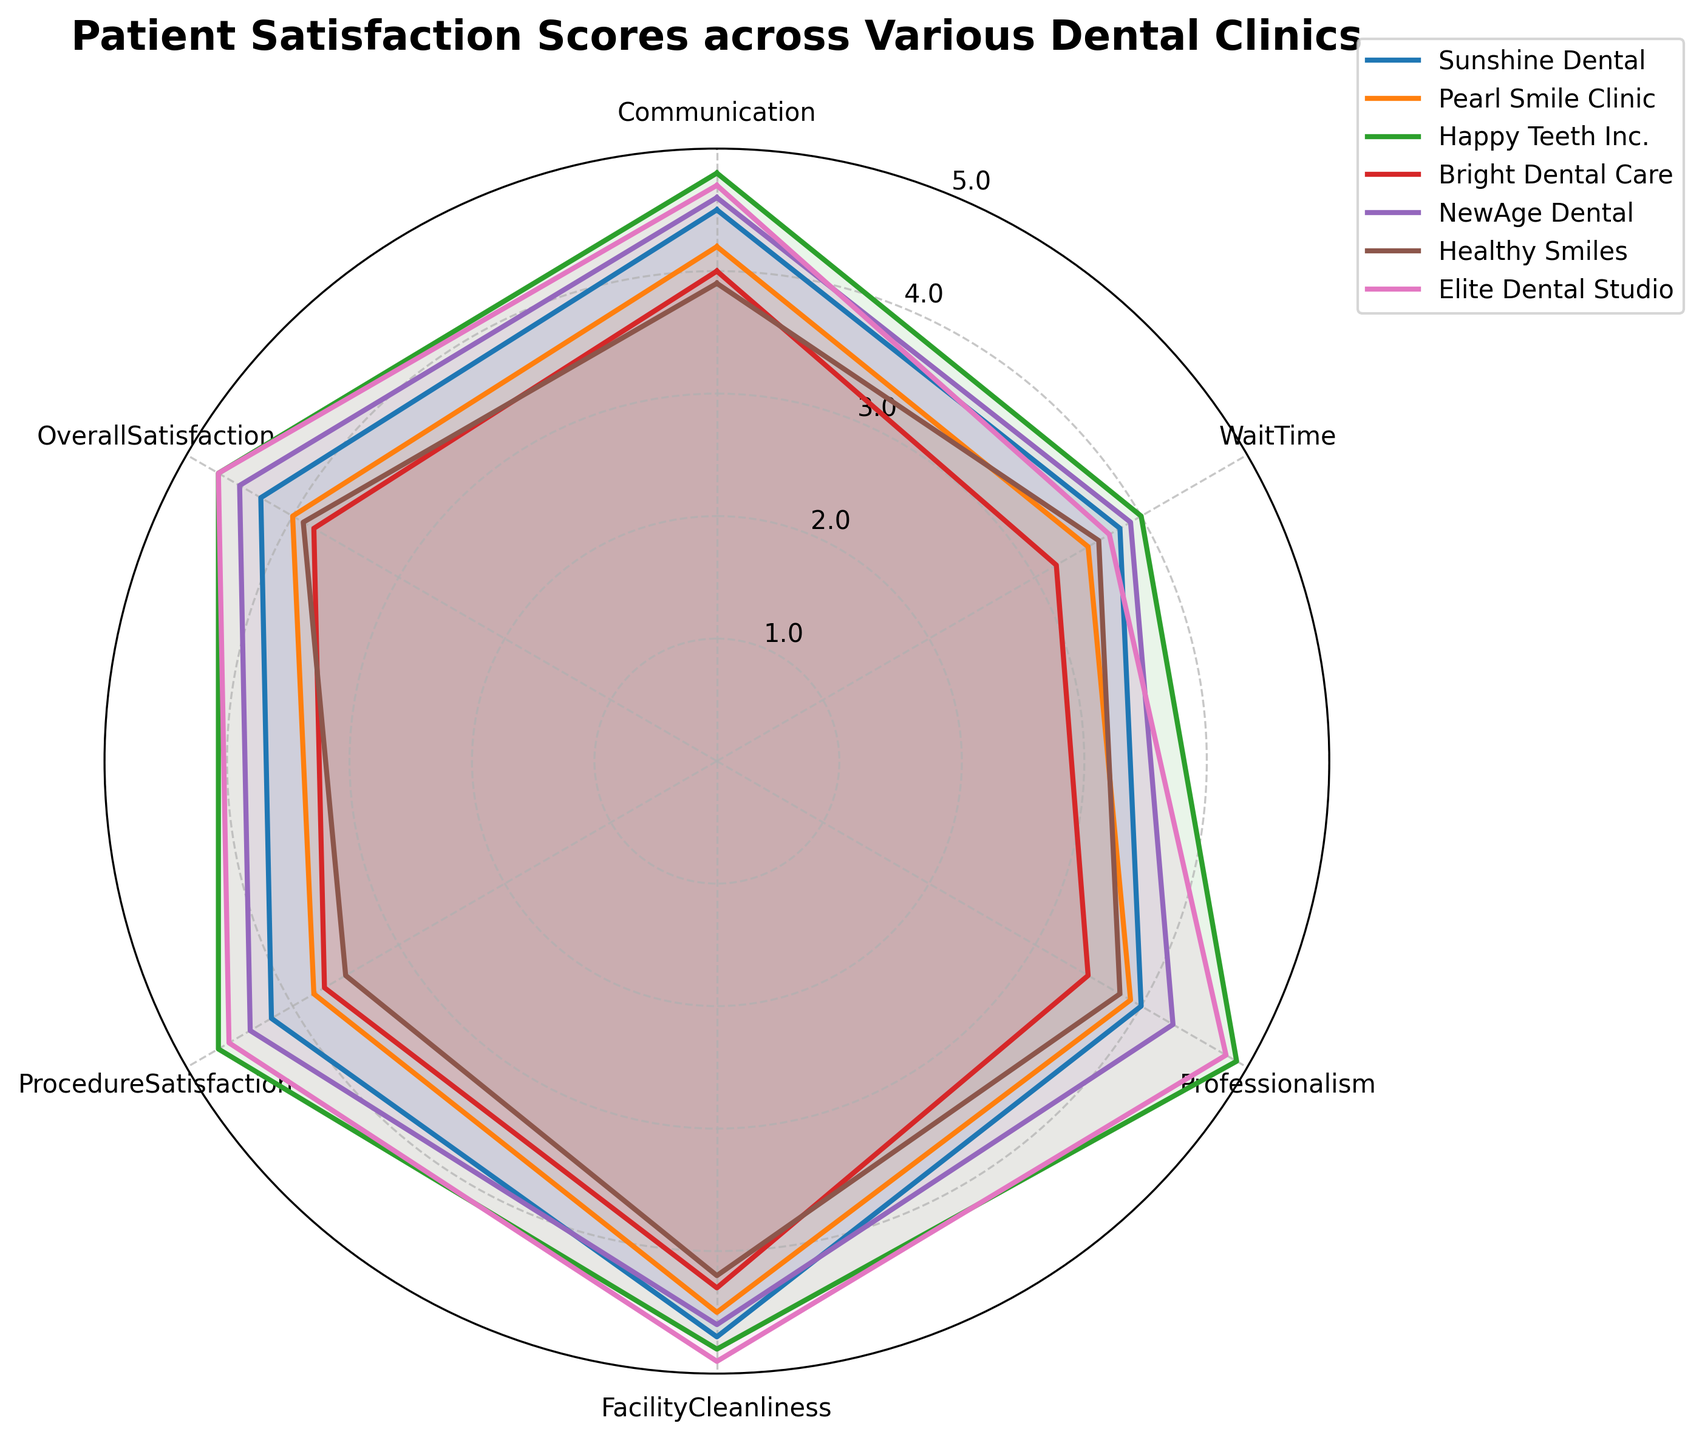How many clinics are included in the radar chart? There are seven different lines representing seven clinics displayed on the chart.
Answer: 7 Which clinic has the highest overall satisfaction score? By looking at the "Overall Satisfaction" point on each clinic's radar plot, Happy Teeth Inc. and Elite Dental Studio both have the highest score at 4.7.
Answer: Happy Teeth Inc. and Elite Dental Studio What is the average score for Procedure Satisfaction among all clinics? Add the Procedure Satisfaction scores for all clinics and then divide by the number of clinics: (4.2 + 3.8 + 4.7 + 3.7 + 4.4 + 3.5 + 4.6) / 7 = 4.1285714.
Answer: 4.13 Which clinic has the lowest score for Wait Time? Compare the Wait Time scores for each clinic and find the lowest value. Bright Dental Care has the lowest score at 3.2.
Answer: Bright Dental Care Do Pearl Smile Clinic and Elite Dental Studio differ in their Communication scores? Pearl Smile Clinic has a Communication score of 4.2, while Elite Dental Studio has a score of 4.7. Therefore, they differ.
Answer: Yes How does Healthy Smiles compare to Sunshine Dental in Professionalism? Healthy Smiles has a score of 3.8 in Professionalism, while Sunshine Dental has a score of 4.0.
Answer: Sunshine Dental scores higher Which clinics score higher than 4.0 in Facility Cleanliness? Identifying clinics with Facility Cleanliness scores higher than 4.0, we have Sunshine Dental (4.7), Pearl Smile Clinic (4.5), Happy Teeth Inc. (4.8), NewAge Dental (4.6), and Elite Dental Studio (4.9).
Answer: Sunshine Dental, Pearl Smile Clinic, Happy Teeth Inc., NewAge Dental, Elite Dental Studio What is the range of Communication scores across all clinics? Finding the difference between the highest and lowest Communication scores: max(4.8, 4.7) - min(3.9) = 4.8 - 3.9 = 0.9.
Answer: 0.9 Which clinic has the most consistent scores across all categories? To find the most consistent scores, we look for the clinic whose radar plot appears the most regular and even. NewAge Dental has very close scores around the 4.5 mark, indicating high consistency.
Answer: NewAge Dental Is the overall trend of "Professionalism" scores across the clinics higher or lower than "Procedure Satisfaction"? By comparing the annual trend of "Professionalism" and "Procedure Satisfaction" scores across all clinics: (4.0+3.9+4.9+3.5+4.3+3.8+4.8)/7 = 4.03 for Professionalism; (4.2+3.8+4.7+3.7+4.4+3.5+4.6)/7 = 4.13 for Procedure Satisfaction. Procedure Satisfaction is generally higher.
Answer: Lower 